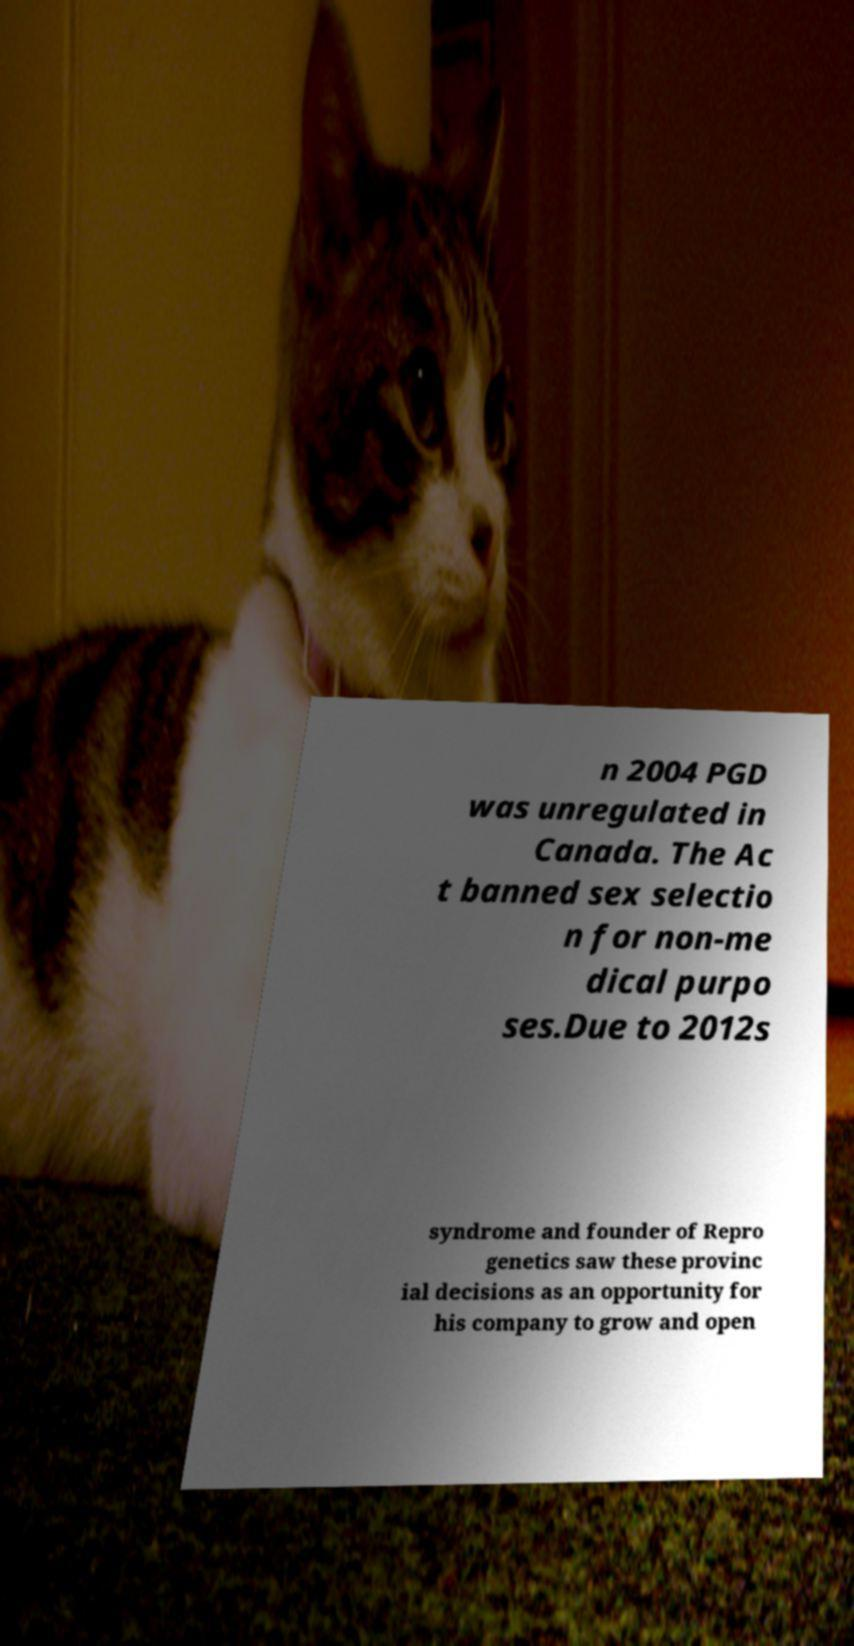There's text embedded in this image that I need extracted. Can you transcribe it verbatim? n 2004 PGD was unregulated in Canada. The Ac t banned sex selectio n for non-me dical purpo ses.Due to 2012s syndrome and founder of Repro genetics saw these provinc ial decisions as an opportunity for his company to grow and open 